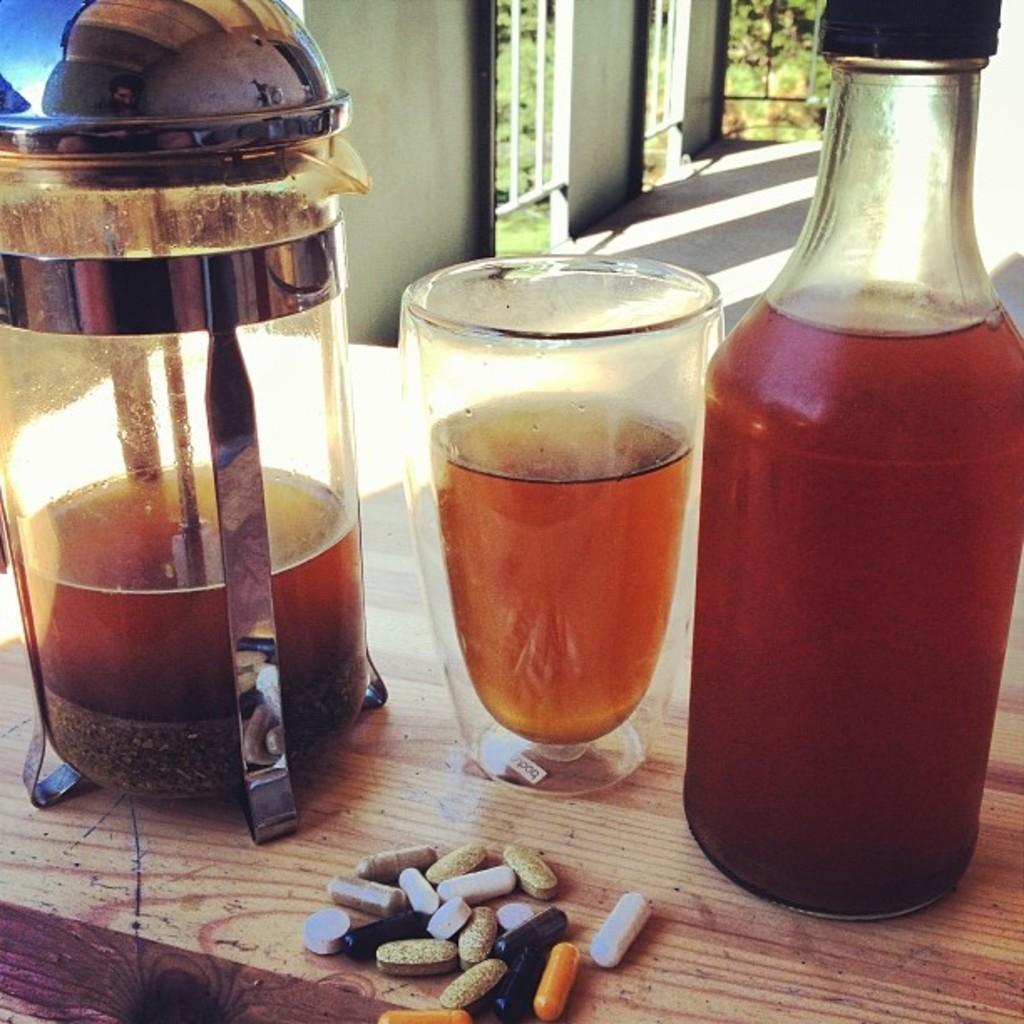How would you summarize this image in a sentence or two? In this image i can see a bottle, a glass and a jar on the table and there are some pills. In the background i can see a window through which i can see trees and also a wall. 